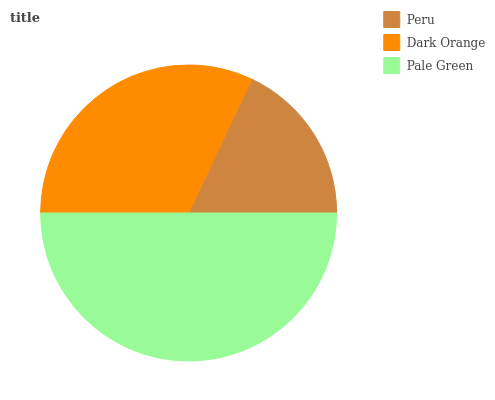Is Peru the minimum?
Answer yes or no. Yes. Is Pale Green the maximum?
Answer yes or no. Yes. Is Dark Orange the minimum?
Answer yes or no. No. Is Dark Orange the maximum?
Answer yes or no. No. Is Dark Orange greater than Peru?
Answer yes or no. Yes. Is Peru less than Dark Orange?
Answer yes or no. Yes. Is Peru greater than Dark Orange?
Answer yes or no. No. Is Dark Orange less than Peru?
Answer yes or no. No. Is Dark Orange the high median?
Answer yes or no. Yes. Is Dark Orange the low median?
Answer yes or no. Yes. Is Peru the high median?
Answer yes or no. No. Is Pale Green the low median?
Answer yes or no. No. 